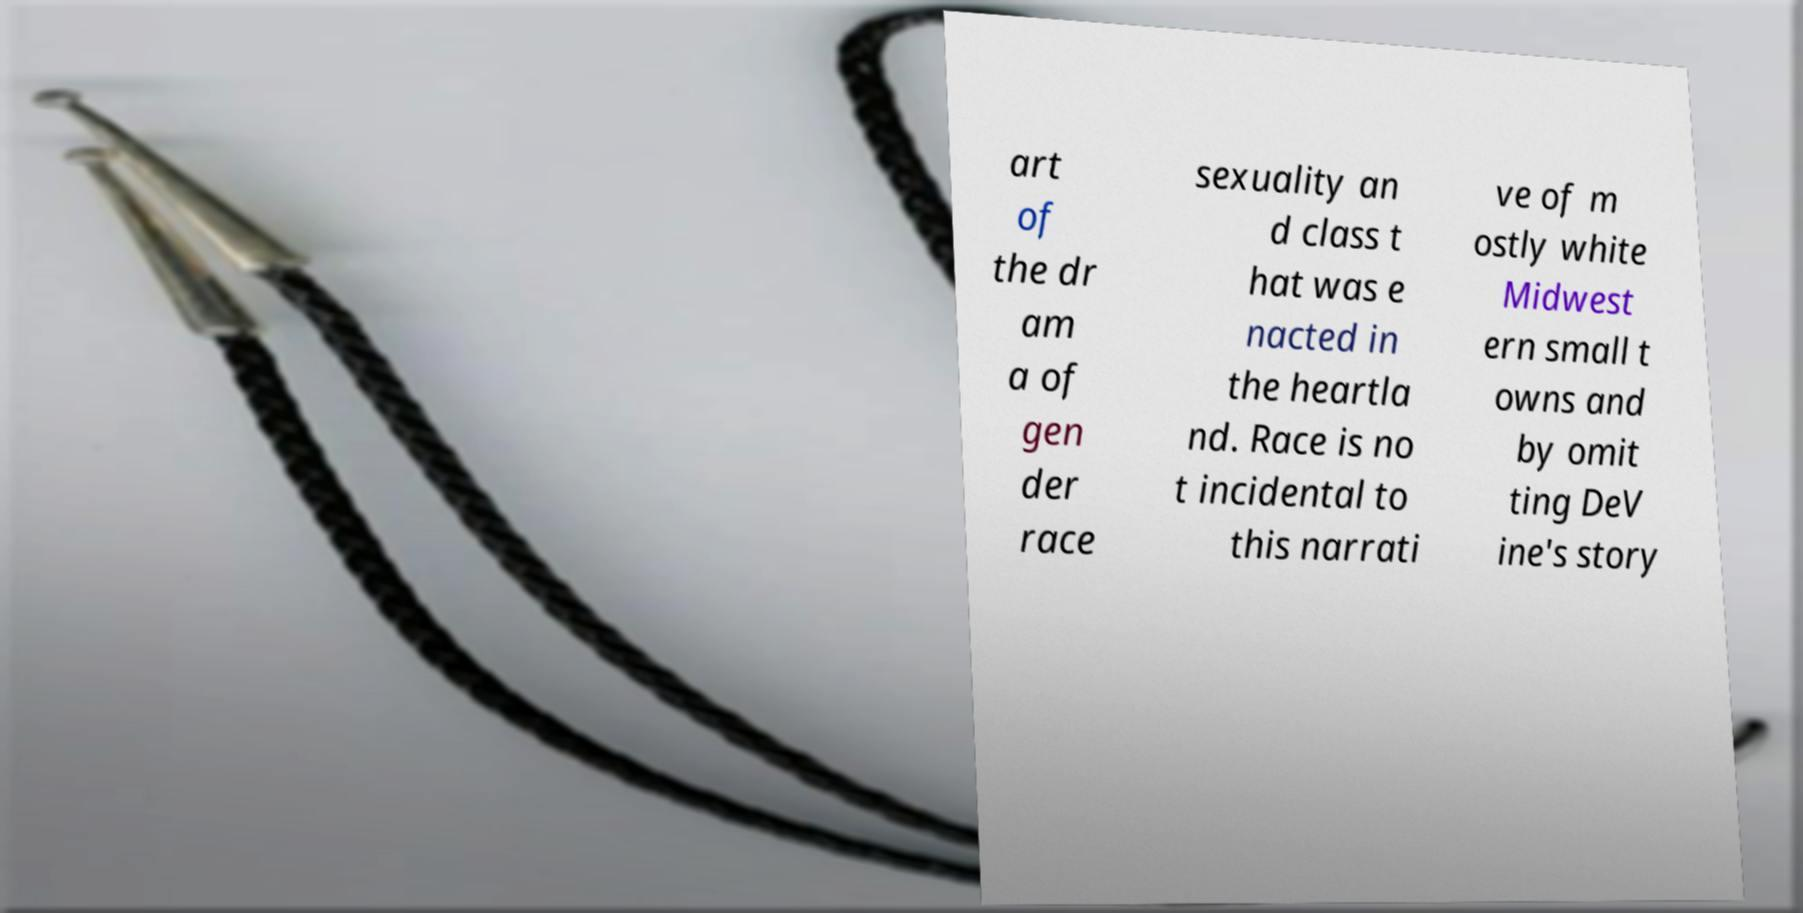Could you assist in decoding the text presented in this image and type it out clearly? art of the dr am a of gen der race sexuality an d class t hat was e nacted in the heartla nd. Race is no t incidental to this narrati ve of m ostly white Midwest ern small t owns and by omit ting DeV ine's story 